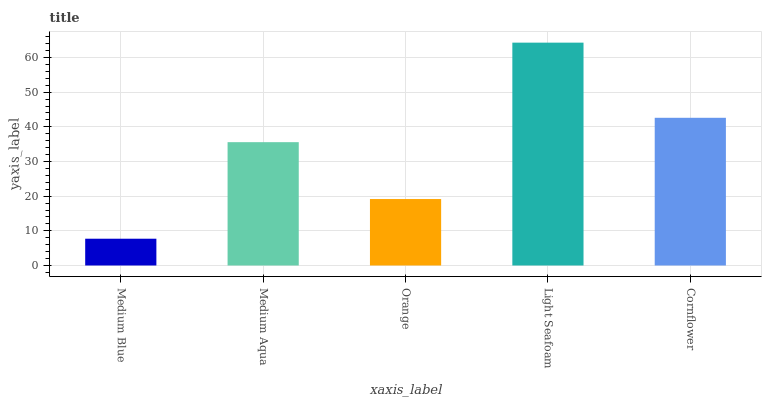Is Medium Blue the minimum?
Answer yes or no. Yes. Is Light Seafoam the maximum?
Answer yes or no. Yes. Is Medium Aqua the minimum?
Answer yes or no. No. Is Medium Aqua the maximum?
Answer yes or no. No. Is Medium Aqua greater than Medium Blue?
Answer yes or no. Yes. Is Medium Blue less than Medium Aqua?
Answer yes or no. Yes. Is Medium Blue greater than Medium Aqua?
Answer yes or no. No. Is Medium Aqua less than Medium Blue?
Answer yes or no. No. Is Medium Aqua the high median?
Answer yes or no. Yes. Is Medium Aqua the low median?
Answer yes or no. Yes. Is Cornflower the high median?
Answer yes or no. No. Is Orange the low median?
Answer yes or no. No. 